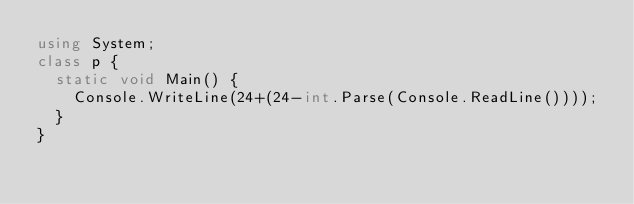<code> <loc_0><loc_0><loc_500><loc_500><_C#_>using System;
class p {
  static void Main() {
    Console.WriteLine(24+(24-int.Parse(Console.ReadLine())));
  }
}</code> 